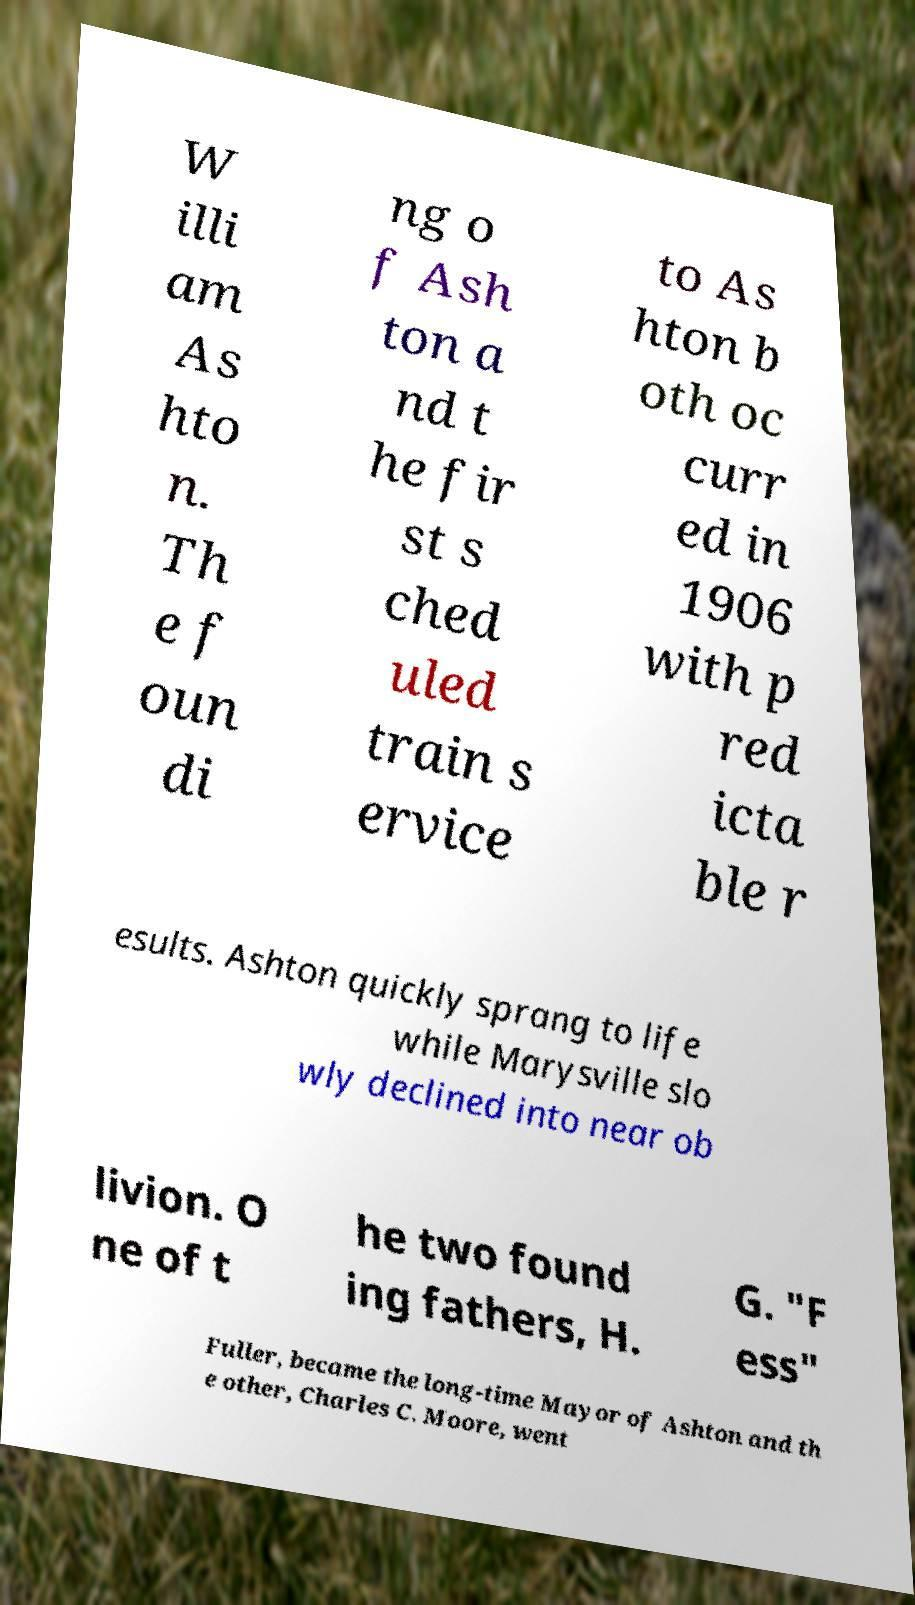Please identify and transcribe the text found in this image. W illi am As hto n. Th e f oun di ng o f Ash ton a nd t he fir st s ched uled train s ervice to As hton b oth oc curr ed in 1906 with p red icta ble r esults. Ashton quickly sprang to life while Marysville slo wly declined into near ob livion. O ne of t he two found ing fathers, H. G. "F ess" Fuller, became the long-time Mayor of Ashton and th e other, Charles C. Moore, went 